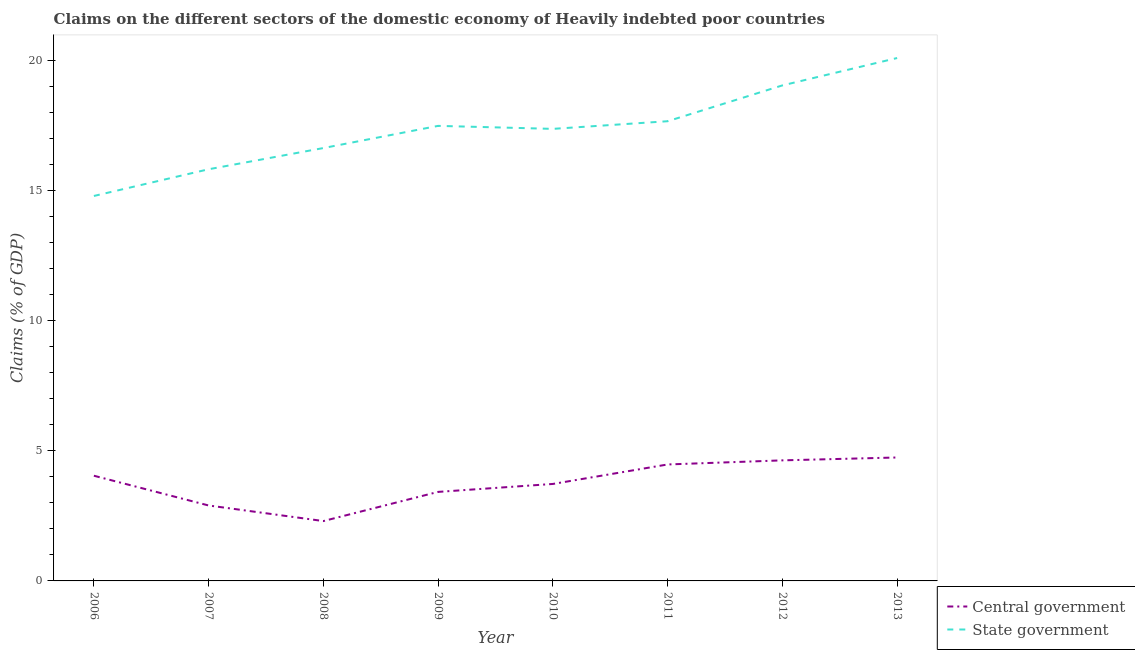Is the number of lines equal to the number of legend labels?
Offer a terse response. Yes. What is the claims on state government in 2007?
Give a very brief answer. 15.81. Across all years, what is the maximum claims on state government?
Ensure brevity in your answer.  20.08. Across all years, what is the minimum claims on state government?
Make the answer very short. 14.78. In which year was the claims on central government minimum?
Offer a very short reply. 2008. What is the total claims on state government in the graph?
Provide a short and direct response. 138.79. What is the difference between the claims on central government in 2010 and that in 2012?
Offer a very short reply. -0.91. What is the difference between the claims on state government in 2006 and the claims on central government in 2007?
Provide a short and direct response. 11.88. What is the average claims on central government per year?
Ensure brevity in your answer.  3.78. In the year 2011, what is the difference between the claims on state government and claims on central government?
Provide a short and direct response. 13.18. What is the ratio of the claims on central government in 2008 to that in 2010?
Give a very brief answer. 0.62. What is the difference between the highest and the second highest claims on state government?
Your answer should be very brief. 1.05. What is the difference between the highest and the lowest claims on state government?
Your answer should be very brief. 5.3. In how many years, is the claims on central government greater than the average claims on central government taken over all years?
Your response must be concise. 4. Does the claims on state government monotonically increase over the years?
Your response must be concise. No. Is the claims on state government strictly greater than the claims on central government over the years?
Provide a short and direct response. Yes. Is the claims on state government strictly less than the claims on central government over the years?
Ensure brevity in your answer.  No. How many years are there in the graph?
Provide a succinct answer. 8. Does the graph contain any zero values?
Ensure brevity in your answer.  No. What is the title of the graph?
Offer a terse response. Claims on the different sectors of the domestic economy of Heavily indebted poor countries. Does "Male" appear as one of the legend labels in the graph?
Keep it short and to the point. No. What is the label or title of the X-axis?
Keep it short and to the point. Year. What is the label or title of the Y-axis?
Ensure brevity in your answer.  Claims (% of GDP). What is the Claims (% of GDP) of Central government in 2006?
Ensure brevity in your answer.  4.04. What is the Claims (% of GDP) in State government in 2006?
Keep it short and to the point. 14.78. What is the Claims (% of GDP) of Central government in 2007?
Ensure brevity in your answer.  2.9. What is the Claims (% of GDP) of State government in 2007?
Your answer should be compact. 15.81. What is the Claims (% of GDP) in Central government in 2008?
Make the answer very short. 2.3. What is the Claims (% of GDP) in State government in 2008?
Provide a succinct answer. 16.62. What is the Claims (% of GDP) in Central government in 2009?
Your answer should be compact. 3.42. What is the Claims (% of GDP) in State government in 2009?
Your answer should be very brief. 17.47. What is the Claims (% of GDP) in Central government in 2010?
Make the answer very short. 3.72. What is the Claims (% of GDP) of State government in 2010?
Provide a short and direct response. 17.36. What is the Claims (% of GDP) in Central government in 2011?
Give a very brief answer. 4.47. What is the Claims (% of GDP) of State government in 2011?
Your answer should be compact. 17.65. What is the Claims (% of GDP) in Central government in 2012?
Offer a terse response. 4.63. What is the Claims (% of GDP) of State government in 2012?
Offer a very short reply. 19.03. What is the Claims (% of GDP) of Central government in 2013?
Your response must be concise. 4.74. What is the Claims (% of GDP) of State government in 2013?
Your answer should be very brief. 20.08. Across all years, what is the maximum Claims (% of GDP) in Central government?
Offer a terse response. 4.74. Across all years, what is the maximum Claims (% of GDP) in State government?
Provide a short and direct response. 20.08. Across all years, what is the minimum Claims (% of GDP) of Central government?
Your answer should be compact. 2.3. Across all years, what is the minimum Claims (% of GDP) in State government?
Your response must be concise. 14.78. What is the total Claims (% of GDP) in Central government in the graph?
Provide a short and direct response. 30.22. What is the total Claims (% of GDP) in State government in the graph?
Offer a very short reply. 138.79. What is the difference between the Claims (% of GDP) of Central government in 2006 and that in 2007?
Provide a succinct answer. 1.14. What is the difference between the Claims (% of GDP) of State government in 2006 and that in 2007?
Provide a succinct answer. -1.03. What is the difference between the Claims (% of GDP) in Central government in 2006 and that in 2008?
Offer a terse response. 1.74. What is the difference between the Claims (% of GDP) of State government in 2006 and that in 2008?
Keep it short and to the point. -1.84. What is the difference between the Claims (% of GDP) in Central government in 2006 and that in 2009?
Give a very brief answer. 0.62. What is the difference between the Claims (% of GDP) in State government in 2006 and that in 2009?
Provide a short and direct response. -2.69. What is the difference between the Claims (% of GDP) of Central government in 2006 and that in 2010?
Keep it short and to the point. 0.32. What is the difference between the Claims (% of GDP) of State government in 2006 and that in 2010?
Make the answer very short. -2.58. What is the difference between the Claims (% of GDP) in Central government in 2006 and that in 2011?
Your answer should be very brief. -0.43. What is the difference between the Claims (% of GDP) of State government in 2006 and that in 2011?
Provide a short and direct response. -2.87. What is the difference between the Claims (% of GDP) in Central government in 2006 and that in 2012?
Make the answer very short. -0.59. What is the difference between the Claims (% of GDP) in State government in 2006 and that in 2012?
Ensure brevity in your answer.  -4.25. What is the difference between the Claims (% of GDP) in Central government in 2006 and that in 2013?
Your answer should be very brief. -0.7. What is the difference between the Claims (% of GDP) of State government in 2006 and that in 2013?
Provide a succinct answer. -5.3. What is the difference between the Claims (% of GDP) of Central government in 2007 and that in 2008?
Your answer should be compact. 0.6. What is the difference between the Claims (% of GDP) of State government in 2007 and that in 2008?
Give a very brief answer. -0.81. What is the difference between the Claims (% of GDP) in Central government in 2007 and that in 2009?
Provide a succinct answer. -0.52. What is the difference between the Claims (% of GDP) in State government in 2007 and that in 2009?
Your answer should be very brief. -1.67. What is the difference between the Claims (% of GDP) in Central government in 2007 and that in 2010?
Your response must be concise. -0.83. What is the difference between the Claims (% of GDP) in State government in 2007 and that in 2010?
Your response must be concise. -1.55. What is the difference between the Claims (% of GDP) of Central government in 2007 and that in 2011?
Ensure brevity in your answer.  -1.58. What is the difference between the Claims (% of GDP) in State government in 2007 and that in 2011?
Give a very brief answer. -1.84. What is the difference between the Claims (% of GDP) of Central government in 2007 and that in 2012?
Your answer should be compact. -1.73. What is the difference between the Claims (% of GDP) in State government in 2007 and that in 2012?
Your answer should be very brief. -3.22. What is the difference between the Claims (% of GDP) in Central government in 2007 and that in 2013?
Give a very brief answer. -1.84. What is the difference between the Claims (% of GDP) in State government in 2007 and that in 2013?
Offer a terse response. -4.27. What is the difference between the Claims (% of GDP) in Central government in 2008 and that in 2009?
Provide a short and direct response. -1.12. What is the difference between the Claims (% of GDP) in State government in 2008 and that in 2009?
Make the answer very short. -0.85. What is the difference between the Claims (% of GDP) in Central government in 2008 and that in 2010?
Your answer should be compact. -1.42. What is the difference between the Claims (% of GDP) in State government in 2008 and that in 2010?
Give a very brief answer. -0.74. What is the difference between the Claims (% of GDP) of Central government in 2008 and that in 2011?
Your answer should be very brief. -2.17. What is the difference between the Claims (% of GDP) in State government in 2008 and that in 2011?
Your answer should be compact. -1.03. What is the difference between the Claims (% of GDP) of Central government in 2008 and that in 2012?
Keep it short and to the point. -2.33. What is the difference between the Claims (% of GDP) in State government in 2008 and that in 2012?
Ensure brevity in your answer.  -2.41. What is the difference between the Claims (% of GDP) in Central government in 2008 and that in 2013?
Provide a short and direct response. -2.44. What is the difference between the Claims (% of GDP) of State government in 2008 and that in 2013?
Make the answer very short. -3.46. What is the difference between the Claims (% of GDP) of Central government in 2009 and that in 2010?
Keep it short and to the point. -0.31. What is the difference between the Claims (% of GDP) of State government in 2009 and that in 2010?
Keep it short and to the point. 0.12. What is the difference between the Claims (% of GDP) in Central government in 2009 and that in 2011?
Provide a short and direct response. -1.05. What is the difference between the Claims (% of GDP) of State government in 2009 and that in 2011?
Your response must be concise. -0.18. What is the difference between the Claims (% of GDP) in Central government in 2009 and that in 2012?
Your answer should be compact. -1.21. What is the difference between the Claims (% of GDP) of State government in 2009 and that in 2012?
Ensure brevity in your answer.  -1.55. What is the difference between the Claims (% of GDP) in Central government in 2009 and that in 2013?
Keep it short and to the point. -1.32. What is the difference between the Claims (% of GDP) in State government in 2009 and that in 2013?
Offer a terse response. -2.6. What is the difference between the Claims (% of GDP) of Central government in 2010 and that in 2011?
Offer a very short reply. -0.75. What is the difference between the Claims (% of GDP) of State government in 2010 and that in 2011?
Offer a terse response. -0.29. What is the difference between the Claims (% of GDP) of Central government in 2010 and that in 2012?
Ensure brevity in your answer.  -0.91. What is the difference between the Claims (% of GDP) of State government in 2010 and that in 2012?
Provide a succinct answer. -1.67. What is the difference between the Claims (% of GDP) in Central government in 2010 and that in 2013?
Make the answer very short. -1.02. What is the difference between the Claims (% of GDP) in State government in 2010 and that in 2013?
Your answer should be compact. -2.72. What is the difference between the Claims (% of GDP) in Central government in 2011 and that in 2012?
Make the answer very short. -0.16. What is the difference between the Claims (% of GDP) of State government in 2011 and that in 2012?
Offer a terse response. -1.38. What is the difference between the Claims (% of GDP) of Central government in 2011 and that in 2013?
Make the answer very short. -0.27. What is the difference between the Claims (% of GDP) in State government in 2011 and that in 2013?
Your answer should be compact. -2.43. What is the difference between the Claims (% of GDP) in Central government in 2012 and that in 2013?
Provide a short and direct response. -0.11. What is the difference between the Claims (% of GDP) in State government in 2012 and that in 2013?
Your answer should be very brief. -1.05. What is the difference between the Claims (% of GDP) of Central government in 2006 and the Claims (% of GDP) of State government in 2007?
Your answer should be very brief. -11.77. What is the difference between the Claims (% of GDP) in Central government in 2006 and the Claims (% of GDP) in State government in 2008?
Provide a succinct answer. -12.58. What is the difference between the Claims (% of GDP) in Central government in 2006 and the Claims (% of GDP) in State government in 2009?
Keep it short and to the point. -13.43. What is the difference between the Claims (% of GDP) in Central government in 2006 and the Claims (% of GDP) in State government in 2010?
Give a very brief answer. -13.32. What is the difference between the Claims (% of GDP) of Central government in 2006 and the Claims (% of GDP) of State government in 2011?
Offer a terse response. -13.61. What is the difference between the Claims (% of GDP) of Central government in 2006 and the Claims (% of GDP) of State government in 2012?
Your answer should be very brief. -14.99. What is the difference between the Claims (% of GDP) in Central government in 2006 and the Claims (% of GDP) in State government in 2013?
Offer a very short reply. -16.04. What is the difference between the Claims (% of GDP) of Central government in 2007 and the Claims (% of GDP) of State government in 2008?
Keep it short and to the point. -13.72. What is the difference between the Claims (% of GDP) of Central government in 2007 and the Claims (% of GDP) of State government in 2009?
Offer a terse response. -14.58. What is the difference between the Claims (% of GDP) of Central government in 2007 and the Claims (% of GDP) of State government in 2010?
Give a very brief answer. -14.46. What is the difference between the Claims (% of GDP) in Central government in 2007 and the Claims (% of GDP) in State government in 2011?
Provide a short and direct response. -14.75. What is the difference between the Claims (% of GDP) of Central government in 2007 and the Claims (% of GDP) of State government in 2012?
Keep it short and to the point. -16.13. What is the difference between the Claims (% of GDP) in Central government in 2007 and the Claims (% of GDP) in State government in 2013?
Offer a very short reply. -17.18. What is the difference between the Claims (% of GDP) in Central government in 2008 and the Claims (% of GDP) in State government in 2009?
Your answer should be very brief. -15.17. What is the difference between the Claims (% of GDP) of Central government in 2008 and the Claims (% of GDP) of State government in 2010?
Offer a terse response. -15.06. What is the difference between the Claims (% of GDP) in Central government in 2008 and the Claims (% of GDP) in State government in 2011?
Your answer should be very brief. -15.35. What is the difference between the Claims (% of GDP) of Central government in 2008 and the Claims (% of GDP) of State government in 2012?
Provide a short and direct response. -16.73. What is the difference between the Claims (% of GDP) in Central government in 2008 and the Claims (% of GDP) in State government in 2013?
Your response must be concise. -17.78. What is the difference between the Claims (% of GDP) in Central government in 2009 and the Claims (% of GDP) in State government in 2010?
Give a very brief answer. -13.94. What is the difference between the Claims (% of GDP) of Central government in 2009 and the Claims (% of GDP) of State government in 2011?
Offer a terse response. -14.23. What is the difference between the Claims (% of GDP) in Central government in 2009 and the Claims (% of GDP) in State government in 2012?
Make the answer very short. -15.61. What is the difference between the Claims (% of GDP) in Central government in 2009 and the Claims (% of GDP) in State government in 2013?
Provide a succinct answer. -16.66. What is the difference between the Claims (% of GDP) of Central government in 2010 and the Claims (% of GDP) of State government in 2011?
Your response must be concise. -13.93. What is the difference between the Claims (% of GDP) in Central government in 2010 and the Claims (% of GDP) in State government in 2012?
Give a very brief answer. -15.3. What is the difference between the Claims (% of GDP) in Central government in 2010 and the Claims (% of GDP) in State government in 2013?
Offer a very short reply. -16.35. What is the difference between the Claims (% of GDP) of Central government in 2011 and the Claims (% of GDP) of State government in 2012?
Ensure brevity in your answer.  -14.55. What is the difference between the Claims (% of GDP) of Central government in 2011 and the Claims (% of GDP) of State government in 2013?
Your response must be concise. -15.61. What is the difference between the Claims (% of GDP) of Central government in 2012 and the Claims (% of GDP) of State government in 2013?
Make the answer very short. -15.45. What is the average Claims (% of GDP) in Central government per year?
Your answer should be compact. 3.78. What is the average Claims (% of GDP) in State government per year?
Make the answer very short. 17.35. In the year 2006, what is the difference between the Claims (% of GDP) of Central government and Claims (% of GDP) of State government?
Your answer should be compact. -10.74. In the year 2007, what is the difference between the Claims (% of GDP) in Central government and Claims (% of GDP) in State government?
Ensure brevity in your answer.  -12.91. In the year 2008, what is the difference between the Claims (% of GDP) in Central government and Claims (% of GDP) in State government?
Your response must be concise. -14.32. In the year 2009, what is the difference between the Claims (% of GDP) in Central government and Claims (% of GDP) in State government?
Make the answer very short. -14.05. In the year 2010, what is the difference between the Claims (% of GDP) in Central government and Claims (% of GDP) in State government?
Provide a short and direct response. -13.63. In the year 2011, what is the difference between the Claims (% of GDP) in Central government and Claims (% of GDP) in State government?
Give a very brief answer. -13.18. In the year 2012, what is the difference between the Claims (% of GDP) in Central government and Claims (% of GDP) in State government?
Provide a short and direct response. -14.4. In the year 2013, what is the difference between the Claims (% of GDP) of Central government and Claims (% of GDP) of State government?
Provide a short and direct response. -15.34. What is the ratio of the Claims (% of GDP) in Central government in 2006 to that in 2007?
Make the answer very short. 1.39. What is the ratio of the Claims (% of GDP) of State government in 2006 to that in 2007?
Your answer should be very brief. 0.94. What is the ratio of the Claims (% of GDP) in Central government in 2006 to that in 2008?
Make the answer very short. 1.76. What is the ratio of the Claims (% of GDP) in State government in 2006 to that in 2008?
Make the answer very short. 0.89. What is the ratio of the Claims (% of GDP) of Central government in 2006 to that in 2009?
Provide a short and direct response. 1.18. What is the ratio of the Claims (% of GDP) in State government in 2006 to that in 2009?
Give a very brief answer. 0.85. What is the ratio of the Claims (% of GDP) in Central government in 2006 to that in 2010?
Your answer should be very brief. 1.08. What is the ratio of the Claims (% of GDP) of State government in 2006 to that in 2010?
Provide a succinct answer. 0.85. What is the ratio of the Claims (% of GDP) in Central government in 2006 to that in 2011?
Provide a succinct answer. 0.9. What is the ratio of the Claims (% of GDP) in State government in 2006 to that in 2011?
Provide a short and direct response. 0.84. What is the ratio of the Claims (% of GDP) in Central government in 2006 to that in 2012?
Your response must be concise. 0.87. What is the ratio of the Claims (% of GDP) in State government in 2006 to that in 2012?
Your response must be concise. 0.78. What is the ratio of the Claims (% of GDP) of Central government in 2006 to that in 2013?
Provide a succinct answer. 0.85. What is the ratio of the Claims (% of GDP) in State government in 2006 to that in 2013?
Give a very brief answer. 0.74. What is the ratio of the Claims (% of GDP) in Central government in 2007 to that in 2008?
Offer a very short reply. 1.26. What is the ratio of the Claims (% of GDP) of State government in 2007 to that in 2008?
Your answer should be very brief. 0.95. What is the ratio of the Claims (% of GDP) of Central government in 2007 to that in 2009?
Give a very brief answer. 0.85. What is the ratio of the Claims (% of GDP) of State government in 2007 to that in 2009?
Offer a very short reply. 0.9. What is the ratio of the Claims (% of GDP) of Central government in 2007 to that in 2010?
Your answer should be compact. 0.78. What is the ratio of the Claims (% of GDP) in State government in 2007 to that in 2010?
Ensure brevity in your answer.  0.91. What is the ratio of the Claims (% of GDP) in Central government in 2007 to that in 2011?
Keep it short and to the point. 0.65. What is the ratio of the Claims (% of GDP) in State government in 2007 to that in 2011?
Your answer should be compact. 0.9. What is the ratio of the Claims (% of GDP) in Central government in 2007 to that in 2012?
Offer a terse response. 0.63. What is the ratio of the Claims (% of GDP) of State government in 2007 to that in 2012?
Offer a terse response. 0.83. What is the ratio of the Claims (% of GDP) in Central government in 2007 to that in 2013?
Keep it short and to the point. 0.61. What is the ratio of the Claims (% of GDP) of State government in 2007 to that in 2013?
Make the answer very short. 0.79. What is the ratio of the Claims (% of GDP) of Central government in 2008 to that in 2009?
Your response must be concise. 0.67. What is the ratio of the Claims (% of GDP) of State government in 2008 to that in 2009?
Your answer should be compact. 0.95. What is the ratio of the Claims (% of GDP) of Central government in 2008 to that in 2010?
Ensure brevity in your answer.  0.62. What is the ratio of the Claims (% of GDP) of State government in 2008 to that in 2010?
Provide a short and direct response. 0.96. What is the ratio of the Claims (% of GDP) in Central government in 2008 to that in 2011?
Ensure brevity in your answer.  0.51. What is the ratio of the Claims (% of GDP) in State government in 2008 to that in 2011?
Provide a short and direct response. 0.94. What is the ratio of the Claims (% of GDP) in Central government in 2008 to that in 2012?
Make the answer very short. 0.5. What is the ratio of the Claims (% of GDP) of State government in 2008 to that in 2012?
Offer a very short reply. 0.87. What is the ratio of the Claims (% of GDP) of Central government in 2008 to that in 2013?
Keep it short and to the point. 0.48. What is the ratio of the Claims (% of GDP) in State government in 2008 to that in 2013?
Your response must be concise. 0.83. What is the ratio of the Claims (% of GDP) of Central government in 2009 to that in 2010?
Your response must be concise. 0.92. What is the ratio of the Claims (% of GDP) of State government in 2009 to that in 2010?
Give a very brief answer. 1.01. What is the ratio of the Claims (% of GDP) of Central government in 2009 to that in 2011?
Keep it short and to the point. 0.76. What is the ratio of the Claims (% of GDP) in State government in 2009 to that in 2011?
Your answer should be very brief. 0.99. What is the ratio of the Claims (% of GDP) in Central government in 2009 to that in 2012?
Keep it short and to the point. 0.74. What is the ratio of the Claims (% of GDP) of State government in 2009 to that in 2012?
Provide a succinct answer. 0.92. What is the ratio of the Claims (% of GDP) in Central government in 2009 to that in 2013?
Keep it short and to the point. 0.72. What is the ratio of the Claims (% of GDP) of State government in 2009 to that in 2013?
Your answer should be compact. 0.87. What is the ratio of the Claims (% of GDP) of Central government in 2010 to that in 2011?
Give a very brief answer. 0.83. What is the ratio of the Claims (% of GDP) of State government in 2010 to that in 2011?
Give a very brief answer. 0.98. What is the ratio of the Claims (% of GDP) of Central government in 2010 to that in 2012?
Your response must be concise. 0.8. What is the ratio of the Claims (% of GDP) in State government in 2010 to that in 2012?
Ensure brevity in your answer.  0.91. What is the ratio of the Claims (% of GDP) in Central government in 2010 to that in 2013?
Give a very brief answer. 0.79. What is the ratio of the Claims (% of GDP) in State government in 2010 to that in 2013?
Provide a succinct answer. 0.86. What is the ratio of the Claims (% of GDP) of State government in 2011 to that in 2012?
Provide a succinct answer. 0.93. What is the ratio of the Claims (% of GDP) in Central government in 2011 to that in 2013?
Give a very brief answer. 0.94. What is the ratio of the Claims (% of GDP) in State government in 2011 to that in 2013?
Provide a short and direct response. 0.88. What is the ratio of the Claims (% of GDP) of Central government in 2012 to that in 2013?
Keep it short and to the point. 0.98. What is the ratio of the Claims (% of GDP) in State government in 2012 to that in 2013?
Give a very brief answer. 0.95. What is the difference between the highest and the second highest Claims (% of GDP) in Central government?
Your answer should be compact. 0.11. What is the difference between the highest and the second highest Claims (% of GDP) in State government?
Provide a short and direct response. 1.05. What is the difference between the highest and the lowest Claims (% of GDP) of Central government?
Provide a succinct answer. 2.44. What is the difference between the highest and the lowest Claims (% of GDP) of State government?
Give a very brief answer. 5.3. 